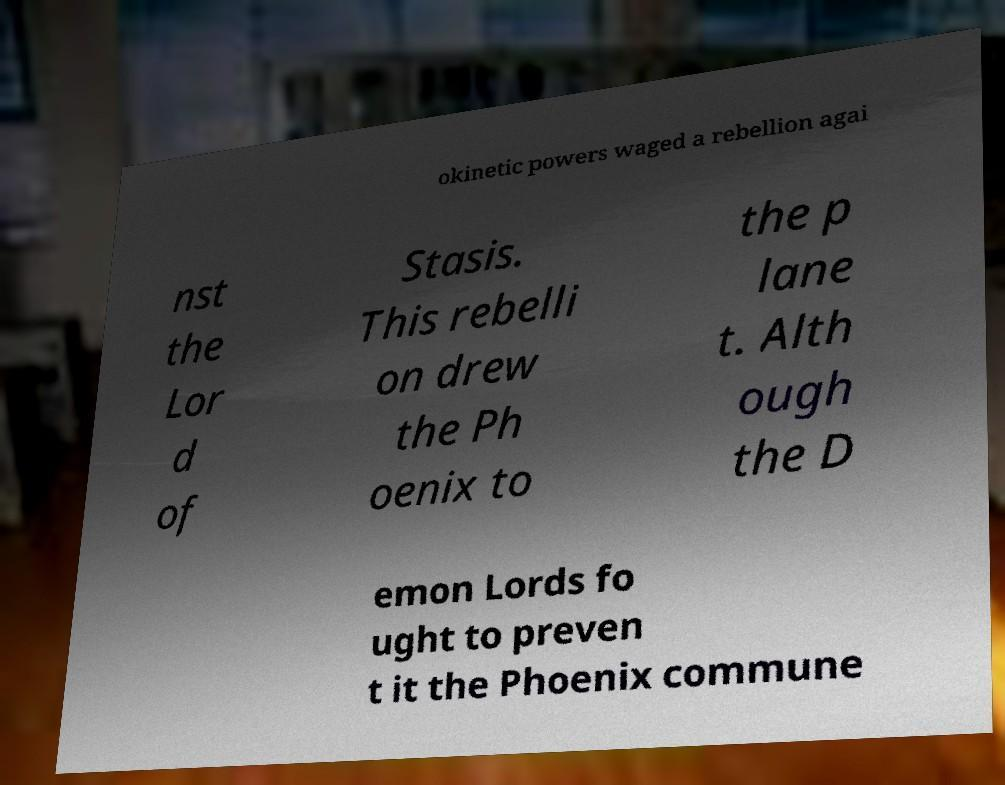Could you assist in decoding the text presented in this image and type it out clearly? okinetic powers waged a rebellion agai nst the Lor d of Stasis. This rebelli on drew the Ph oenix to the p lane t. Alth ough the D emon Lords fo ught to preven t it the Phoenix commune 